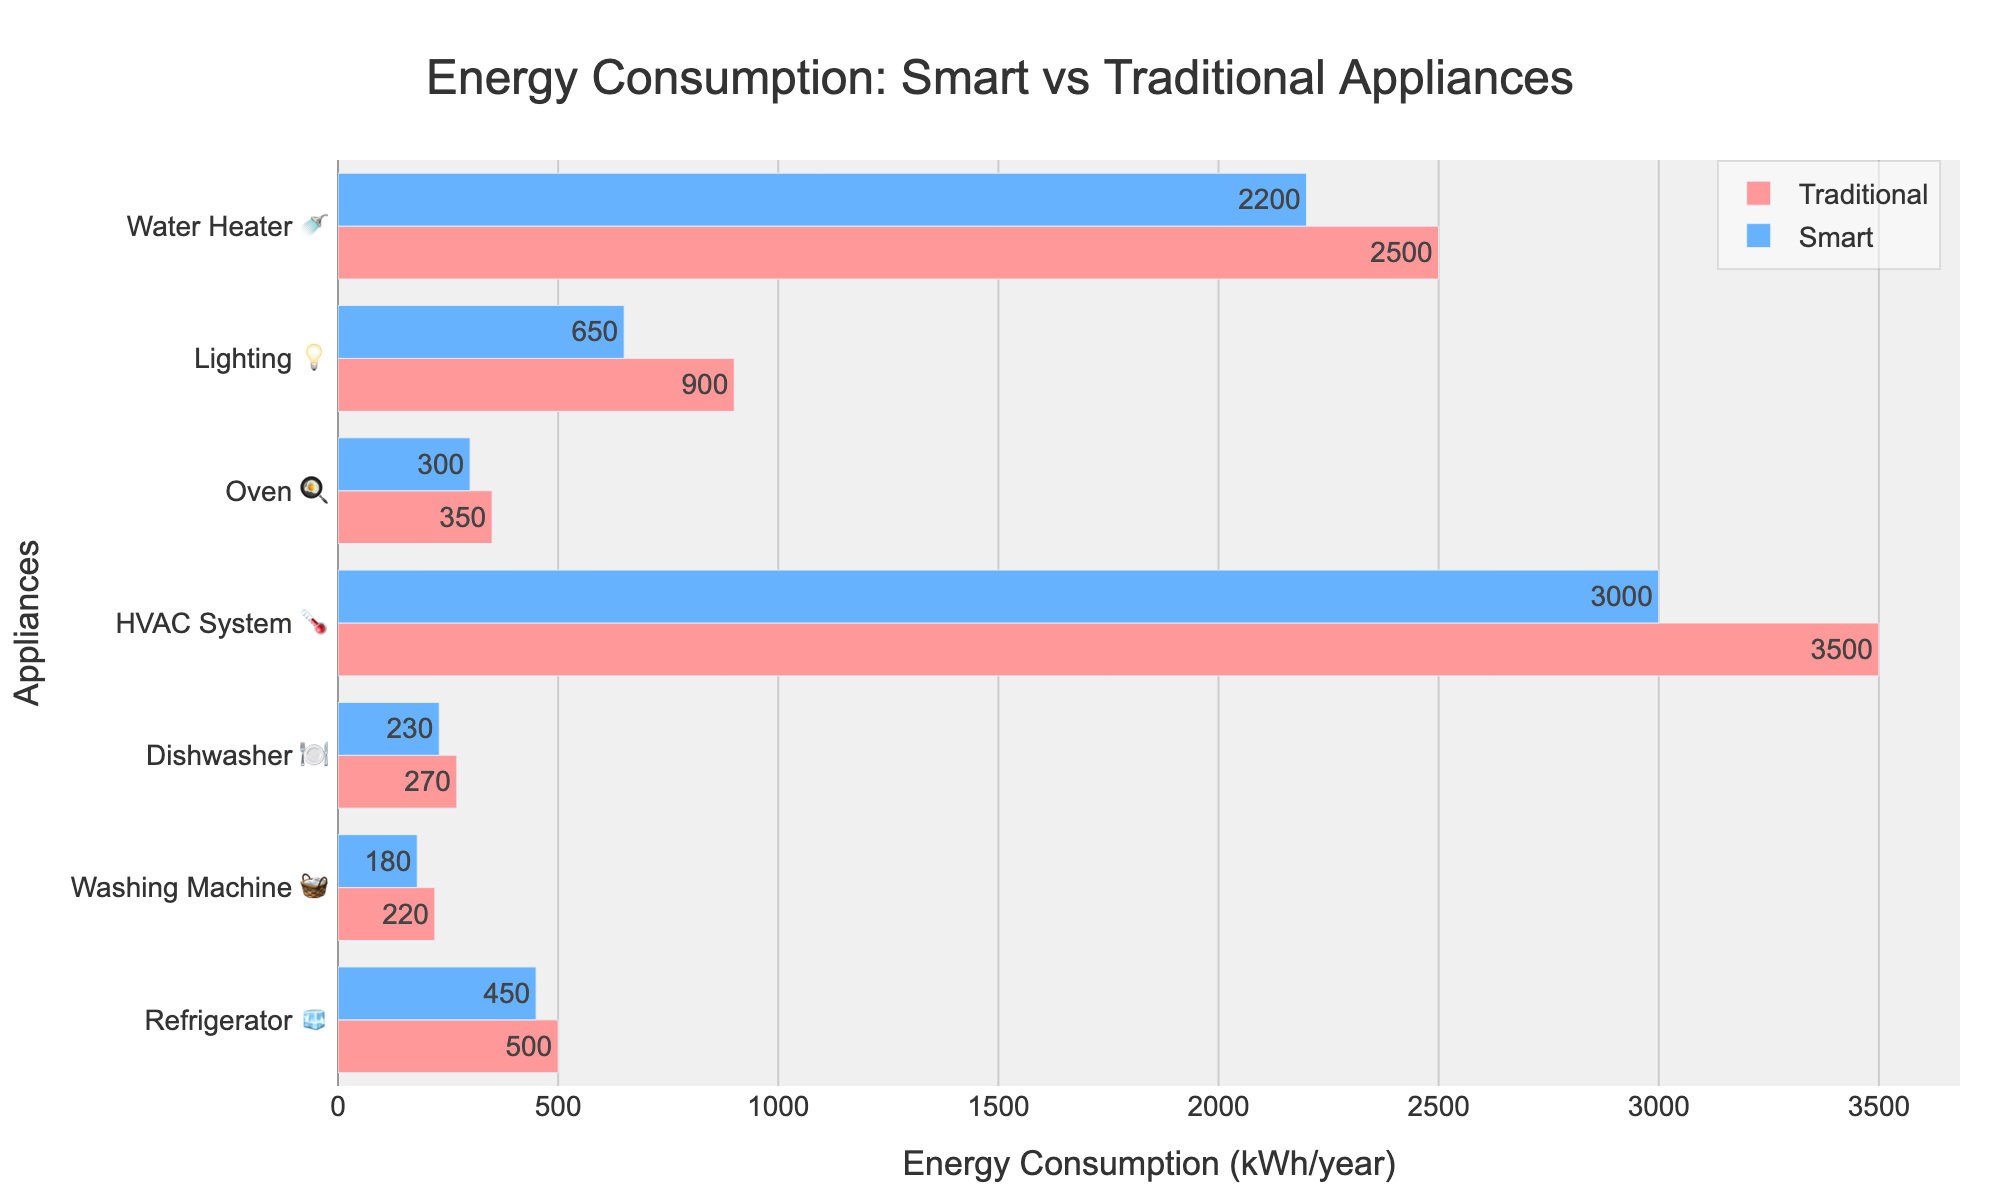What's the title of the chart? The title of the chart is located at the top center of the figure in bold and is often used to provide a summary of what the chart represents. It says "Energy Consumption: Smart vs Traditional Appliances".
Answer: Energy Consumption: Smart vs Traditional Appliances What is the energy consumption of a smart Washing Machine? The bar chart includes horizontal bars for each appliance, with their energy consumption values directly labeled. Looking at the smart Washing Machine, we see the figure 180 kWh/year.
Answer: 180 kWh/year Which appliance has the largest reduction in energy consumption when using a smart version compared to the traditional version? To identify the appliance with the largest reduction, check the difference in energy consumption for each appliance. The HVAC System has the largest reduction, dropping from 3500 kWh/year to 3000 kWh/year (a reduction of 500 kWh/year).
Answer: HVAC System How much less energy does a smart Oven use compared to a traditional Oven? The traditional Oven consumes 350 kWh/year and the smart Oven consumes 300 kWh/year. Subtracting these values, 350 - 300 = 50 kWh/year.
Answer: 50 kWh/year What's the total energy consumption for smart versions of Refrigerator, Dishwasher, and Water Heater combined? Add the energy consumption of each smart appliance: Refrigerator (450 kWh/year), Dishwasher (230 kWh/year), and Water Heater (2200 kWh/year). The total is 450 + 230 + 2200 = 2880 kWh/year.
Answer: 2880 kWh/year Which smart appliance uses the least energy per year? By examining the smart appliance bars in the figure, the Washing Machine has the lowest value at 180 kWh/year.
Answer: Washing Machine Do traditional or smart appliances generally consume more energy? Comparing the lengths of the bars, traditional appliances consistently show higher values than their smart counterparts.
Answer: Traditional How much energy would be saved annually by switching from traditional to smart Lighting? Traditional Lighting uses 900 kWh/year, and smart Lighting uses 650 kWh/year. The savings is 900 - 650 = 250 kWh/year.
Answer: 250 kWh/year What is the average energy consumption of traditional home appliances? Sum the energy values for traditional appliances (500 + 220 + 270 + 3500 + 350 + 900 + 2500) = 8240 kWh/year, then divide by the number of appliances (7). 8240 / 7 = 1177.14 kWh/year (rounded to 2 decimal places).
Answer: 1177.14 kWh/year 